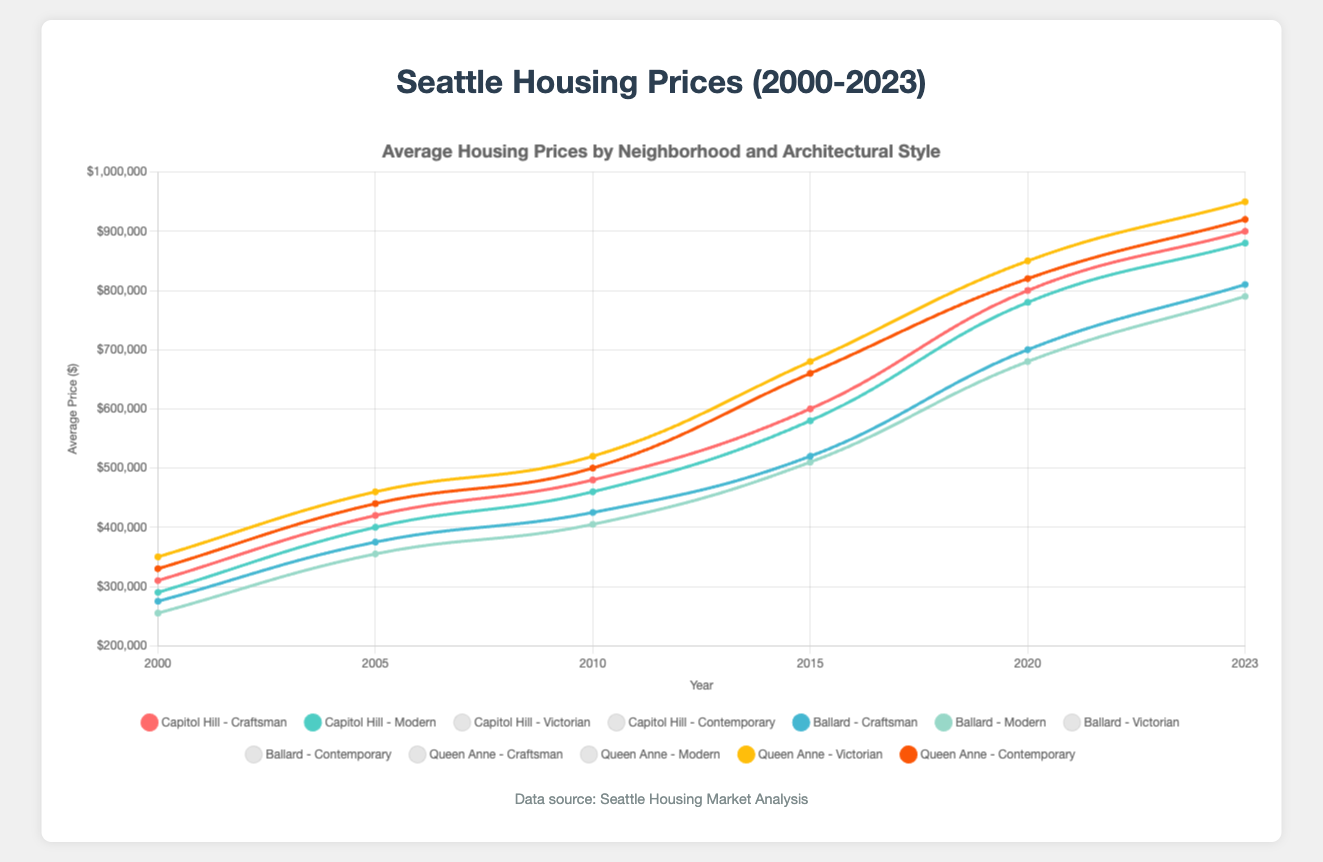Which neighborhood saw the highest increase in average housing prices from 2000 to 2023? First, look at the legend to identify the colors representing each neighborhood. Then, compare the heights of the curves for each neighborhood between 2000 and 2023 to see which one had the largest upward shift. Queen Anne's Victorian houses increased from $350,000 in 2000 to $950,000 in 2023, which is the highest increase.
Answer: Queen Anne Which architectural style in Capitol Hill had more significant price growth from 2000 to 2023, Craftsman or Modern? Compare the price changes for Craftsman and Modern styles in Capitol Hill from 2000 to 2023. The Craftsman style increased from $310,000 to $900,000, while the Modern style increased from $290,000 to $880,000.
Answer: Craftsman What is the average of the prices of Victorian homes in Queen Anne in the years 2000, 2010, and 2020? Add the prices of Victorian homes in Queen Anne for the given years: $350,000 (2000) + $520,000 (2010) + $850,000 (2020). Divide this sum by 3 to get the average.
Answer: $573,333 By how much did the average price of Modern homes in Ballard increase between 2015 and 2023? Subtract the average price of Modern homes in Ballard in 2015 ($510,000) from the average price in 2023 ($790,000).
Answer: $280,000 Which neighborhood consistently had the highest average prices for Victorian homes throughout the years? Look at the curves for Victorian homes in different neighborhoods and compare their heights over the years. The curve for Victorian homes in Queen Anne is consistently higher.
Answer: Queen Anne Between 2000 and 2023, in which year did Capitol Hill Craftsman homes first surpass $500,000? Follow the curve for Capitol Hill Craftsman homes and identify the year in which it first exceeds the $500,000 mark. This occurs around 2015.
Answer: 2015 Compare the overall price trends for Modern homes between Ballard and Capitol Hill. Which one experienced higher growth at the end of the period? Examine the slopes and end points of the curves for Modern homes in Ballard and Capitol Hill. Capitol Hill's Modern homes increased from $290,000 to $880,000, while Ballard's increased from $255,000 to $790,000.
Answer: Capitol Hill What visual pattern do you observe about the price changes in the three neighborhoods over the plotted years? Observe the general trends in the curves for all neighborhoods. All neighborhoods exhibit upward trends, indicating increasing prices. Queen Anne shows the steepest increase consistently.
Answer: Upward trend, steepest in Queen Anne 